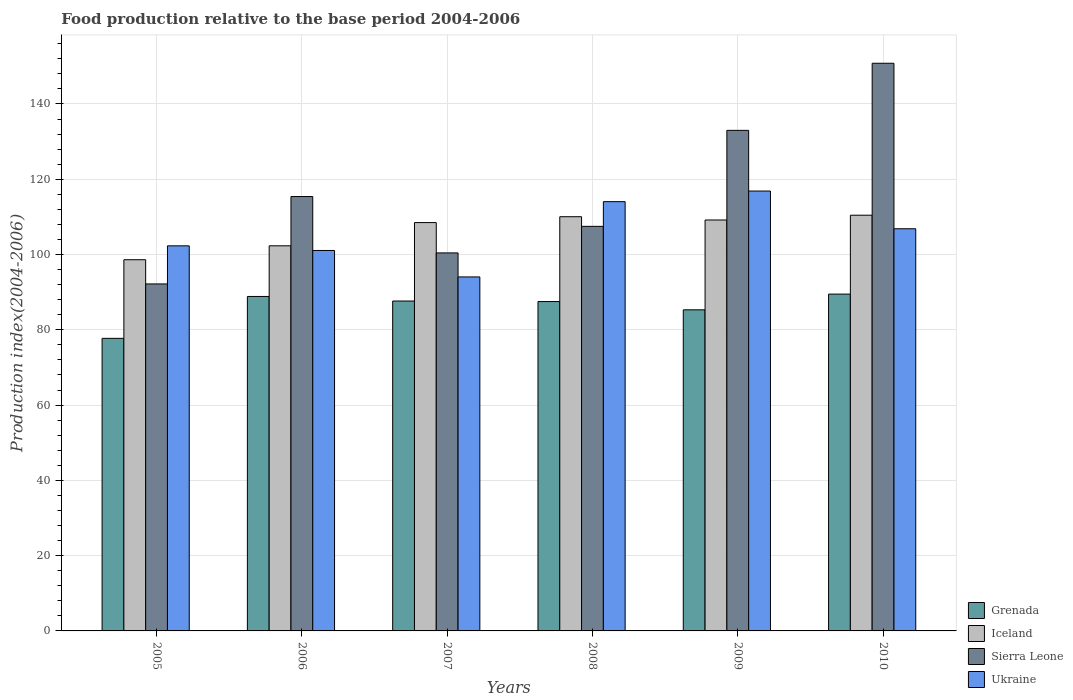How many groups of bars are there?
Keep it short and to the point. 6. Are the number of bars per tick equal to the number of legend labels?
Give a very brief answer. Yes. Are the number of bars on each tick of the X-axis equal?
Provide a short and direct response. Yes. What is the label of the 4th group of bars from the left?
Your answer should be compact. 2008. In how many cases, is the number of bars for a given year not equal to the number of legend labels?
Give a very brief answer. 0. What is the food production index in Grenada in 2010?
Offer a very short reply. 89.49. Across all years, what is the maximum food production index in Iceland?
Offer a terse response. 110.45. Across all years, what is the minimum food production index in Grenada?
Offer a terse response. 77.73. In which year was the food production index in Ukraine maximum?
Offer a very short reply. 2009. What is the total food production index in Ukraine in the graph?
Your response must be concise. 635.21. What is the difference between the food production index in Grenada in 2006 and that in 2010?
Give a very brief answer. -0.63. What is the difference between the food production index in Ukraine in 2005 and the food production index in Grenada in 2009?
Provide a succinct answer. 17. What is the average food production index in Iceland per year?
Offer a terse response. 106.52. In the year 2008, what is the difference between the food production index in Iceland and food production index in Ukraine?
Provide a short and direct response. -4. In how many years, is the food production index in Ukraine greater than 136?
Your response must be concise. 0. What is the ratio of the food production index in Grenada in 2005 to that in 2007?
Give a very brief answer. 0.89. Is the food production index in Iceland in 2006 less than that in 2010?
Offer a very short reply. Yes. Is the difference between the food production index in Iceland in 2009 and 2010 greater than the difference between the food production index in Ukraine in 2009 and 2010?
Ensure brevity in your answer.  No. What is the difference between the highest and the second highest food production index in Iceland?
Provide a short and direct response. 0.4. What is the difference between the highest and the lowest food production index in Iceland?
Provide a short and direct response. 11.83. Is it the case that in every year, the sum of the food production index in Ukraine and food production index in Iceland is greater than the sum of food production index in Sierra Leone and food production index in Grenada?
Provide a short and direct response. No. What does the 1st bar from the left in 2009 represents?
Your answer should be very brief. Grenada. What does the 1st bar from the right in 2008 represents?
Your answer should be very brief. Ukraine. How many bars are there?
Your answer should be compact. 24. Are all the bars in the graph horizontal?
Your response must be concise. No. What is the difference between two consecutive major ticks on the Y-axis?
Your response must be concise. 20. How many legend labels are there?
Offer a very short reply. 4. How are the legend labels stacked?
Provide a short and direct response. Vertical. What is the title of the graph?
Give a very brief answer. Food production relative to the base period 2004-2006. Does "Vanuatu" appear as one of the legend labels in the graph?
Make the answer very short. No. What is the label or title of the Y-axis?
Make the answer very short. Production index(2004-2006). What is the Production index(2004-2006) in Grenada in 2005?
Ensure brevity in your answer.  77.73. What is the Production index(2004-2006) of Iceland in 2005?
Your answer should be compact. 98.62. What is the Production index(2004-2006) in Sierra Leone in 2005?
Your answer should be compact. 92.19. What is the Production index(2004-2006) in Ukraine in 2005?
Your answer should be compact. 102.31. What is the Production index(2004-2006) in Grenada in 2006?
Make the answer very short. 88.86. What is the Production index(2004-2006) in Iceland in 2006?
Your answer should be very brief. 102.32. What is the Production index(2004-2006) of Sierra Leone in 2006?
Ensure brevity in your answer.  115.41. What is the Production index(2004-2006) in Ukraine in 2006?
Make the answer very short. 101.08. What is the Production index(2004-2006) in Grenada in 2007?
Offer a terse response. 87.65. What is the Production index(2004-2006) in Iceland in 2007?
Keep it short and to the point. 108.49. What is the Production index(2004-2006) of Sierra Leone in 2007?
Keep it short and to the point. 100.43. What is the Production index(2004-2006) in Ukraine in 2007?
Your answer should be compact. 94.05. What is the Production index(2004-2006) of Grenada in 2008?
Your response must be concise. 87.51. What is the Production index(2004-2006) of Iceland in 2008?
Provide a succinct answer. 110.05. What is the Production index(2004-2006) in Sierra Leone in 2008?
Offer a very short reply. 107.49. What is the Production index(2004-2006) in Ukraine in 2008?
Provide a succinct answer. 114.05. What is the Production index(2004-2006) of Grenada in 2009?
Give a very brief answer. 85.31. What is the Production index(2004-2006) in Iceland in 2009?
Your response must be concise. 109.18. What is the Production index(2004-2006) in Sierra Leone in 2009?
Your response must be concise. 132.99. What is the Production index(2004-2006) of Ukraine in 2009?
Make the answer very short. 116.87. What is the Production index(2004-2006) of Grenada in 2010?
Provide a succinct answer. 89.49. What is the Production index(2004-2006) of Iceland in 2010?
Offer a terse response. 110.45. What is the Production index(2004-2006) in Sierra Leone in 2010?
Offer a very short reply. 150.82. What is the Production index(2004-2006) in Ukraine in 2010?
Ensure brevity in your answer.  106.85. Across all years, what is the maximum Production index(2004-2006) in Grenada?
Keep it short and to the point. 89.49. Across all years, what is the maximum Production index(2004-2006) of Iceland?
Keep it short and to the point. 110.45. Across all years, what is the maximum Production index(2004-2006) of Sierra Leone?
Give a very brief answer. 150.82. Across all years, what is the maximum Production index(2004-2006) in Ukraine?
Provide a short and direct response. 116.87. Across all years, what is the minimum Production index(2004-2006) in Grenada?
Keep it short and to the point. 77.73. Across all years, what is the minimum Production index(2004-2006) of Iceland?
Your answer should be compact. 98.62. Across all years, what is the minimum Production index(2004-2006) of Sierra Leone?
Provide a succinct answer. 92.19. Across all years, what is the minimum Production index(2004-2006) in Ukraine?
Ensure brevity in your answer.  94.05. What is the total Production index(2004-2006) in Grenada in the graph?
Ensure brevity in your answer.  516.55. What is the total Production index(2004-2006) of Iceland in the graph?
Provide a short and direct response. 639.11. What is the total Production index(2004-2006) of Sierra Leone in the graph?
Give a very brief answer. 699.33. What is the total Production index(2004-2006) in Ukraine in the graph?
Keep it short and to the point. 635.21. What is the difference between the Production index(2004-2006) of Grenada in 2005 and that in 2006?
Offer a very short reply. -11.13. What is the difference between the Production index(2004-2006) in Iceland in 2005 and that in 2006?
Your response must be concise. -3.7. What is the difference between the Production index(2004-2006) of Sierra Leone in 2005 and that in 2006?
Offer a very short reply. -23.22. What is the difference between the Production index(2004-2006) of Ukraine in 2005 and that in 2006?
Your answer should be compact. 1.23. What is the difference between the Production index(2004-2006) of Grenada in 2005 and that in 2007?
Ensure brevity in your answer.  -9.92. What is the difference between the Production index(2004-2006) of Iceland in 2005 and that in 2007?
Your answer should be very brief. -9.87. What is the difference between the Production index(2004-2006) of Sierra Leone in 2005 and that in 2007?
Ensure brevity in your answer.  -8.24. What is the difference between the Production index(2004-2006) in Ukraine in 2005 and that in 2007?
Provide a short and direct response. 8.26. What is the difference between the Production index(2004-2006) of Grenada in 2005 and that in 2008?
Provide a succinct answer. -9.78. What is the difference between the Production index(2004-2006) in Iceland in 2005 and that in 2008?
Give a very brief answer. -11.43. What is the difference between the Production index(2004-2006) of Sierra Leone in 2005 and that in 2008?
Ensure brevity in your answer.  -15.3. What is the difference between the Production index(2004-2006) in Ukraine in 2005 and that in 2008?
Your response must be concise. -11.74. What is the difference between the Production index(2004-2006) in Grenada in 2005 and that in 2009?
Keep it short and to the point. -7.58. What is the difference between the Production index(2004-2006) in Iceland in 2005 and that in 2009?
Give a very brief answer. -10.56. What is the difference between the Production index(2004-2006) in Sierra Leone in 2005 and that in 2009?
Offer a terse response. -40.8. What is the difference between the Production index(2004-2006) of Ukraine in 2005 and that in 2009?
Give a very brief answer. -14.56. What is the difference between the Production index(2004-2006) of Grenada in 2005 and that in 2010?
Make the answer very short. -11.76. What is the difference between the Production index(2004-2006) of Iceland in 2005 and that in 2010?
Keep it short and to the point. -11.83. What is the difference between the Production index(2004-2006) of Sierra Leone in 2005 and that in 2010?
Your answer should be compact. -58.63. What is the difference between the Production index(2004-2006) in Ukraine in 2005 and that in 2010?
Your answer should be very brief. -4.54. What is the difference between the Production index(2004-2006) in Grenada in 2006 and that in 2007?
Keep it short and to the point. 1.21. What is the difference between the Production index(2004-2006) in Iceland in 2006 and that in 2007?
Keep it short and to the point. -6.17. What is the difference between the Production index(2004-2006) in Sierra Leone in 2006 and that in 2007?
Ensure brevity in your answer.  14.98. What is the difference between the Production index(2004-2006) in Ukraine in 2006 and that in 2007?
Your response must be concise. 7.03. What is the difference between the Production index(2004-2006) in Grenada in 2006 and that in 2008?
Your response must be concise. 1.35. What is the difference between the Production index(2004-2006) of Iceland in 2006 and that in 2008?
Provide a succinct answer. -7.73. What is the difference between the Production index(2004-2006) of Sierra Leone in 2006 and that in 2008?
Your response must be concise. 7.92. What is the difference between the Production index(2004-2006) in Ukraine in 2006 and that in 2008?
Give a very brief answer. -12.97. What is the difference between the Production index(2004-2006) of Grenada in 2006 and that in 2009?
Ensure brevity in your answer.  3.55. What is the difference between the Production index(2004-2006) in Iceland in 2006 and that in 2009?
Keep it short and to the point. -6.86. What is the difference between the Production index(2004-2006) of Sierra Leone in 2006 and that in 2009?
Provide a succinct answer. -17.58. What is the difference between the Production index(2004-2006) of Ukraine in 2006 and that in 2009?
Provide a short and direct response. -15.79. What is the difference between the Production index(2004-2006) in Grenada in 2006 and that in 2010?
Offer a very short reply. -0.63. What is the difference between the Production index(2004-2006) of Iceland in 2006 and that in 2010?
Offer a terse response. -8.13. What is the difference between the Production index(2004-2006) of Sierra Leone in 2006 and that in 2010?
Ensure brevity in your answer.  -35.41. What is the difference between the Production index(2004-2006) in Ukraine in 2006 and that in 2010?
Make the answer very short. -5.77. What is the difference between the Production index(2004-2006) in Grenada in 2007 and that in 2008?
Provide a succinct answer. 0.14. What is the difference between the Production index(2004-2006) in Iceland in 2007 and that in 2008?
Ensure brevity in your answer.  -1.56. What is the difference between the Production index(2004-2006) of Sierra Leone in 2007 and that in 2008?
Provide a succinct answer. -7.06. What is the difference between the Production index(2004-2006) of Grenada in 2007 and that in 2009?
Your answer should be compact. 2.34. What is the difference between the Production index(2004-2006) of Iceland in 2007 and that in 2009?
Ensure brevity in your answer.  -0.69. What is the difference between the Production index(2004-2006) in Sierra Leone in 2007 and that in 2009?
Offer a very short reply. -32.56. What is the difference between the Production index(2004-2006) of Ukraine in 2007 and that in 2009?
Provide a succinct answer. -22.82. What is the difference between the Production index(2004-2006) of Grenada in 2007 and that in 2010?
Provide a succinct answer. -1.84. What is the difference between the Production index(2004-2006) of Iceland in 2007 and that in 2010?
Keep it short and to the point. -1.96. What is the difference between the Production index(2004-2006) in Sierra Leone in 2007 and that in 2010?
Give a very brief answer. -50.39. What is the difference between the Production index(2004-2006) of Grenada in 2008 and that in 2009?
Your answer should be compact. 2.2. What is the difference between the Production index(2004-2006) of Iceland in 2008 and that in 2009?
Your response must be concise. 0.87. What is the difference between the Production index(2004-2006) in Sierra Leone in 2008 and that in 2009?
Offer a very short reply. -25.5. What is the difference between the Production index(2004-2006) in Ukraine in 2008 and that in 2009?
Offer a terse response. -2.82. What is the difference between the Production index(2004-2006) of Grenada in 2008 and that in 2010?
Your response must be concise. -1.98. What is the difference between the Production index(2004-2006) in Iceland in 2008 and that in 2010?
Keep it short and to the point. -0.4. What is the difference between the Production index(2004-2006) in Sierra Leone in 2008 and that in 2010?
Ensure brevity in your answer.  -43.33. What is the difference between the Production index(2004-2006) of Ukraine in 2008 and that in 2010?
Make the answer very short. 7.2. What is the difference between the Production index(2004-2006) in Grenada in 2009 and that in 2010?
Your response must be concise. -4.18. What is the difference between the Production index(2004-2006) of Iceland in 2009 and that in 2010?
Offer a very short reply. -1.27. What is the difference between the Production index(2004-2006) in Sierra Leone in 2009 and that in 2010?
Provide a short and direct response. -17.83. What is the difference between the Production index(2004-2006) of Ukraine in 2009 and that in 2010?
Make the answer very short. 10.02. What is the difference between the Production index(2004-2006) of Grenada in 2005 and the Production index(2004-2006) of Iceland in 2006?
Your response must be concise. -24.59. What is the difference between the Production index(2004-2006) of Grenada in 2005 and the Production index(2004-2006) of Sierra Leone in 2006?
Offer a terse response. -37.68. What is the difference between the Production index(2004-2006) in Grenada in 2005 and the Production index(2004-2006) in Ukraine in 2006?
Your answer should be compact. -23.35. What is the difference between the Production index(2004-2006) in Iceland in 2005 and the Production index(2004-2006) in Sierra Leone in 2006?
Ensure brevity in your answer.  -16.79. What is the difference between the Production index(2004-2006) in Iceland in 2005 and the Production index(2004-2006) in Ukraine in 2006?
Your response must be concise. -2.46. What is the difference between the Production index(2004-2006) of Sierra Leone in 2005 and the Production index(2004-2006) of Ukraine in 2006?
Ensure brevity in your answer.  -8.89. What is the difference between the Production index(2004-2006) of Grenada in 2005 and the Production index(2004-2006) of Iceland in 2007?
Offer a very short reply. -30.76. What is the difference between the Production index(2004-2006) of Grenada in 2005 and the Production index(2004-2006) of Sierra Leone in 2007?
Keep it short and to the point. -22.7. What is the difference between the Production index(2004-2006) in Grenada in 2005 and the Production index(2004-2006) in Ukraine in 2007?
Your response must be concise. -16.32. What is the difference between the Production index(2004-2006) in Iceland in 2005 and the Production index(2004-2006) in Sierra Leone in 2007?
Your answer should be compact. -1.81. What is the difference between the Production index(2004-2006) in Iceland in 2005 and the Production index(2004-2006) in Ukraine in 2007?
Offer a very short reply. 4.57. What is the difference between the Production index(2004-2006) of Sierra Leone in 2005 and the Production index(2004-2006) of Ukraine in 2007?
Offer a very short reply. -1.86. What is the difference between the Production index(2004-2006) in Grenada in 2005 and the Production index(2004-2006) in Iceland in 2008?
Your answer should be very brief. -32.32. What is the difference between the Production index(2004-2006) of Grenada in 2005 and the Production index(2004-2006) of Sierra Leone in 2008?
Ensure brevity in your answer.  -29.76. What is the difference between the Production index(2004-2006) in Grenada in 2005 and the Production index(2004-2006) in Ukraine in 2008?
Give a very brief answer. -36.32. What is the difference between the Production index(2004-2006) of Iceland in 2005 and the Production index(2004-2006) of Sierra Leone in 2008?
Ensure brevity in your answer.  -8.87. What is the difference between the Production index(2004-2006) of Iceland in 2005 and the Production index(2004-2006) of Ukraine in 2008?
Your answer should be very brief. -15.43. What is the difference between the Production index(2004-2006) of Sierra Leone in 2005 and the Production index(2004-2006) of Ukraine in 2008?
Your response must be concise. -21.86. What is the difference between the Production index(2004-2006) in Grenada in 2005 and the Production index(2004-2006) in Iceland in 2009?
Offer a terse response. -31.45. What is the difference between the Production index(2004-2006) of Grenada in 2005 and the Production index(2004-2006) of Sierra Leone in 2009?
Make the answer very short. -55.26. What is the difference between the Production index(2004-2006) of Grenada in 2005 and the Production index(2004-2006) of Ukraine in 2009?
Keep it short and to the point. -39.14. What is the difference between the Production index(2004-2006) of Iceland in 2005 and the Production index(2004-2006) of Sierra Leone in 2009?
Your answer should be very brief. -34.37. What is the difference between the Production index(2004-2006) of Iceland in 2005 and the Production index(2004-2006) of Ukraine in 2009?
Your answer should be very brief. -18.25. What is the difference between the Production index(2004-2006) of Sierra Leone in 2005 and the Production index(2004-2006) of Ukraine in 2009?
Ensure brevity in your answer.  -24.68. What is the difference between the Production index(2004-2006) in Grenada in 2005 and the Production index(2004-2006) in Iceland in 2010?
Keep it short and to the point. -32.72. What is the difference between the Production index(2004-2006) of Grenada in 2005 and the Production index(2004-2006) of Sierra Leone in 2010?
Your answer should be compact. -73.09. What is the difference between the Production index(2004-2006) of Grenada in 2005 and the Production index(2004-2006) of Ukraine in 2010?
Give a very brief answer. -29.12. What is the difference between the Production index(2004-2006) in Iceland in 2005 and the Production index(2004-2006) in Sierra Leone in 2010?
Your answer should be compact. -52.2. What is the difference between the Production index(2004-2006) in Iceland in 2005 and the Production index(2004-2006) in Ukraine in 2010?
Ensure brevity in your answer.  -8.23. What is the difference between the Production index(2004-2006) in Sierra Leone in 2005 and the Production index(2004-2006) in Ukraine in 2010?
Keep it short and to the point. -14.66. What is the difference between the Production index(2004-2006) of Grenada in 2006 and the Production index(2004-2006) of Iceland in 2007?
Provide a succinct answer. -19.63. What is the difference between the Production index(2004-2006) of Grenada in 2006 and the Production index(2004-2006) of Sierra Leone in 2007?
Provide a short and direct response. -11.57. What is the difference between the Production index(2004-2006) in Grenada in 2006 and the Production index(2004-2006) in Ukraine in 2007?
Make the answer very short. -5.19. What is the difference between the Production index(2004-2006) in Iceland in 2006 and the Production index(2004-2006) in Sierra Leone in 2007?
Provide a short and direct response. 1.89. What is the difference between the Production index(2004-2006) in Iceland in 2006 and the Production index(2004-2006) in Ukraine in 2007?
Give a very brief answer. 8.27. What is the difference between the Production index(2004-2006) of Sierra Leone in 2006 and the Production index(2004-2006) of Ukraine in 2007?
Your answer should be compact. 21.36. What is the difference between the Production index(2004-2006) in Grenada in 2006 and the Production index(2004-2006) in Iceland in 2008?
Ensure brevity in your answer.  -21.19. What is the difference between the Production index(2004-2006) of Grenada in 2006 and the Production index(2004-2006) of Sierra Leone in 2008?
Your response must be concise. -18.63. What is the difference between the Production index(2004-2006) of Grenada in 2006 and the Production index(2004-2006) of Ukraine in 2008?
Keep it short and to the point. -25.19. What is the difference between the Production index(2004-2006) of Iceland in 2006 and the Production index(2004-2006) of Sierra Leone in 2008?
Ensure brevity in your answer.  -5.17. What is the difference between the Production index(2004-2006) of Iceland in 2006 and the Production index(2004-2006) of Ukraine in 2008?
Your response must be concise. -11.73. What is the difference between the Production index(2004-2006) in Sierra Leone in 2006 and the Production index(2004-2006) in Ukraine in 2008?
Ensure brevity in your answer.  1.36. What is the difference between the Production index(2004-2006) of Grenada in 2006 and the Production index(2004-2006) of Iceland in 2009?
Offer a very short reply. -20.32. What is the difference between the Production index(2004-2006) of Grenada in 2006 and the Production index(2004-2006) of Sierra Leone in 2009?
Your answer should be very brief. -44.13. What is the difference between the Production index(2004-2006) in Grenada in 2006 and the Production index(2004-2006) in Ukraine in 2009?
Keep it short and to the point. -28.01. What is the difference between the Production index(2004-2006) of Iceland in 2006 and the Production index(2004-2006) of Sierra Leone in 2009?
Your answer should be compact. -30.67. What is the difference between the Production index(2004-2006) of Iceland in 2006 and the Production index(2004-2006) of Ukraine in 2009?
Provide a succinct answer. -14.55. What is the difference between the Production index(2004-2006) in Sierra Leone in 2006 and the Production index(2004-2006) in Ukraine in 2009?
Offer a very short reply. -1.46. What is the difference between the Production index(2004-2006) in Grenada in 2006 and the Production index(2004-2006) in Iceland in 2010?
Ensure brevity in your answer.  -21.59. What is the difference between the Production index(2004-2006) in Grenada in 2006 and the Production index(2004-2006) in Sierra Leone in 2010?
Offer a very short reply. -61.96. What is the difference between the Production index(2004-2006) of Grenada in 2006 and the Production index(2004-2006) of Ukraine in 2010?
Your answer should be very brief. -17.99. What is the difference between the Production index(2004-2006) of Iceland in 2006 and the Production index(2004-2006) of Sierra Leone in 2010?
Give a very brief answer. -48.5. What is the difference between the Production index(2004-2006) of Iceland in 2006 and the Production index(2004-2006) of Ukraine in 2010?
Provide a succinct answer. -4.53. What is the difference between the Production index(2004-2006) of Sierra Leone in 2006 and the Production index(2004-2006) of Ukraine in 2010?
Offer a very short reply. 8.56. What is the difference between the Production index(2004-2006) in Grenada in 2007 and the Production index(2004-2006) in Iceland in 2008?
Your answer should be compact. -22.4. What is the difference between the Production index(2004-2006) of Grenada in 2007 and the Production index(2004-2006) of Sierra Leone in 2008?
Offer a terse response. -19.84. What is the difference between the Production index(2004-2006) in Grenada in 2007 and the Production index(2004-2006) in Ukraine in 2008?
Your response must be concise. -26.4. What is the difference between the Production index(2004-2006) in Iceland in 2007 and the Production index(2004-2006) in Sierra Leone in 2008?
Offer a terse response. 1. What is the difference between the Production index(2004-2006) in Iceland in 2007 and the Production index(2004-2006) in Ukraine in 2008?
Provide a short and direct response. -5.56. What is the difference between the Production index(2004-2006) of Sierra Leone in 2007 and the Production index(2004-2006) of Ukraine in 2008?
Your response must be concise. -13.62. What is the difference between the Production index(2004-2006) in Grenada in 2007 and the Production index(2004-2006) in Iceland in 2009?
Provide a short and direct response. -21.53. What is the difference between the Production index(2004-2006) in Grenada in 2007 and the Production index(2004-2006) in Sierra Leone in 2009?
Provide a succinct answer. -45.34. What is the difference between the Production index(2004-2006) of Grenada in 2007 and the Production index(2004-2006) of Ukraine in 2009?
Provide a short and direct response. -29.22. What is the difference between the Production index(2004-2006) of Iceland in 2007 and the Production index(2004-2006) of Sierra Leone in 2009?
Ensure brevity in your answer.  -24.5. What is the difference between the Production index(2004-2006) in Iceland in 2007 and the Production index(2004-2006) in Ukraine in 2009?
Your answer should be compact. -8.38. What is the difference between the Production index(2004-2006) of Sierra Leone in 2007 and the Production index(2004-2006) of Ukraine in 2009?
Keep it short and to the point. -16.44. What is the difference between the Production index(2004-2006) in Grenada in 2007 and the Production index(2004-2006) in Iceland in 2010?
Provide a short and direct response. -22.8. What is the difference between the Production index(2004-2006) in Grenada in 2007 and the Production index(2004-2006) in Sierra Leone in 2010?
Your answer should be compact. -63.17. What is the difference between the Production index(2004-2006) of Grenada in 2007 and the Production index(2004-2006) of Ukraine in 2010?
Your answer should be very brief. -19.2. What is the difference between the Production index(2004-2006) in Iceland in 2007 and the Production index(2004-2006) in Sierra Leone in 2010?
Keep it short and to the point. -42.33. What is the difference between the Production index(2004-2006) in Iceland in 2007 and the Production index(2004-2006) in Ukraine in 2010?
Your response must be concise. 1.64. What is the difference between the Production index(2004-2006) in Sierra Leone in 2007 and the Production index(2004-2006) in Ukraine in 2010?
Provide a short and direct response. -6.42. What is the difference between the Production index(2004-2006) of Grenada in 2008 and the Production index(2004-2006) of Iceland in 2009?
Ensure brevity in your answer.  -21.67. What is the difference between the Production index(2004-2006) of Grenada in 2008 and the Production index(2004-2006) of Sierra Leone in 2009?
Make the answer very short. -45.48. What is the difference between the Production index(2004-2006) in Grenada in 2008 and the Production index(2004-2006) in Ukraine in 2009?
Your answer should be very brief. -29.36. What is the difference between the Production index(2004-2006) in Iceland in 2008 and the Production index(2004-2006) in Sierra Leone in 2009?
Your answer should be compact. -22.94. What is the difference between the Production index(2004-2006) of Iceland in 2008 and the Production index(2004-2006) of Ukraine in 2009?
Provide a succinct answer. -6.82. What is the difference between the Production index(2004-2006) in Sierra Leone in 2008 and the Production index(2004-2006) in Ukraine in 2009?
Make the answer very short. -9.38. What is the difference between the Production index(2004-2006) of Grenada in 2008 and the Production index(2004-2006) of Iceland in 2010?
Ensure brevity in your answer.  -22.94. What is the difference between the Production index(2004-2006) of Grenada in 2008 and the Production index(2004-2006) of Sierra Leone in 2010?
Keep it short and to the point. -63.31. What is the difference between the Production index(2004-2006) in Grenada in 2008 and the Production index(2004-2006) in Ukraine in 2010?
Offer a terse response. -19.34. What is the difference between the Production index(2004-2006) of Iceland in 2008 and the Production index(2004-2006) of Sierra Leone in 2010?
Your response must be concise. -40.77. What is the difference between the Production index(2004-2006) of Iceland in 2008 and the Production index(2004-2006) of Ukraine in 2010?
Make the answer very short. 3.2. What is the difference between the Production index(2004-2006) of Sierra Leone in 2008 and the Production index(2004-2006) of Ukraine in 2010?
Your answer should be compact. 0.64. What is the difference between the Production index(2004-2006) of Grenada in 2009 and the Production index(2004-2006) of Iceland in 2010?
Offer a very short reply. -25.14. What is the difference between the Production index(2004-2006) in Grenada in 2009 and the Production index(2004-2006) in Sierra Leone in 2010?
Keep it short and to the point. -65.51. What is the difference between the Production index(2004-2006) of Grenada in 2009 and the Production index(2004-2006) of Ukraine in 2010?
Provide a succinct answer. -21.54. What is the difference between the Production index(2004-2006) of Iceland in 2009 and the Production index(2004-2006) of Sierra Leone in 2010?
Your answer should be very brief. -41.64. What is the difference between the Production index(2004-2006) in Iceland in 2009 and the Production index(2004-2006) in Ukraine in 2010?
Offer a very short reply. 2.33. What is the difference between the Production index(2004-2006) of Sierra Leone in 2009 and the Production index(2004-2006) of Ukraine in 2010?
Your answer should be compact. 26.14. What is the average Production index(2004-2006) in Grenada per year?
Offer a terse response. 86.09. What is the average Production index(2004-2006) of Iceland per year?
Provide a succinct answer. 106.52. What is the average Production index(2004-2006) in Sierra Leone per year?
Offer a very short reply. 116.56. What is the average Production index(2004-2006) in Ukraine per year?
Your answer should be compact. 105.87. In the year 2005, what is the difference between the Production index(2004-2006) of Grenada and Production index(2004-2006) of Iceland?
Give a very brief answer. -20.89. In the year 2005, what is the difference between the Production index(2004-2006) in Grenada and Production index(2004-2006) in Sierra Leone?
Provide a short and direct response. -14.46. In the year 2005, what is the difference between the Production index(2004-2006) of Grenada and Production index(2004-2006) of Ukraine?
Keep it short and to the point. -24.58. In the year 2005, what is the difference between the Production index(2004-2006) of Iceland and Production index(2004-2006) of Sierra Leone?
Your response must be concise. 6.43. In the year 2005, what is the difference between the Production index(2004-2006) in Iceland and Production index(2004-2006) in Ukraine?
Offer a very short reply. -3.69. In the year 2005, what is the difference between the Production index(2004-2006) in Sierra Leone and Production index(2004-2006) in Ukraine?
Ensure brevity in your answer.  -10.12. In the year 2006, what is the difference between the Production index(2004-2006) in Grenada and Production index(2004-2006) in Iceland?
Keep it short and to the point. -13.46. In the year 2006, what is the difference between the Production index(2004-2006) of Grenada and Production index(2004-2006) of Sierra Leone?
Offer a very short reply. -26.55. In the year 2006, what is the difference between the Production index(2004-2006) in Grenada and Production index(2004-2006) in Ukraine?
Offer a terse response. -12.22. In the year 2006, what is the difference between the Production index(2004-2006) in Iceland and Production index(2004-2006) in Sierra Leone?
Your answer should be very brief. -13.09. In the year 2006, what is the difference between the Production index(2004-2006) in Iceland and Production index(2004-2006) in Ukraine?
Provide a short and direct response. 1.24. In the year 2006, what is the difference between the Production index(2004-2006) of Sierra Leone and Production index(2004-2006) of Ukraine?
Your response must be concise. 14.33. In the year 2007, what is the difference between the Production index(2004-2006) of Grenada and Production index(2004-2006) of Iceland?
Offer a very short reply. -20.84. In the year 2007, what is the difference between the Production index(2004-2006) in Grenada and Production index(2004-2006) in Sierra Leone?
Your response must be concise. -12.78. In the year 2007, what is the difference between the Production index(2004-2006) in Iceland and Production index(2004-2006) in Sierra Leone?
Your answer should be compact. 8.06. In the year 2007, what is the difference between the Production index(2004-2006) in Iceland and Production index(2004-2006) in Ukraine?
Offer a terse response. 14.44. In the year 2007, what is the difference between the Production index(2004-2006) of Sierra Leone and Production index(2004-2006) of Ukraine?
Your answer should be compact. 6.38. In the year 2008, what is the difference between the Production index(2004-2006) of Grenada and Production index(2004-2006) of Iceland?
Keep it short and to the point. -22.54. In the year 2008, what is the difference between the Production index(2004-2006) of Grenada and Production index(2004-2006) of Sierra Leone?
Your response must be concise. -19.98. In the year 2008, what is the difference between the Production index(2004-2006) in Grenada and Production index(2004-2006) in Ukraine?
Give a very brief answer. -26.54. In the year 2008, what is the difference between the Production index(2004-2006) in Iceland and Production index(2004-2006) in Sierra Leone?
Make the answer very short. 2.56. In the year 2008, what is the difference between the Production index(2004-2006) in Iceland and Production index(2004-2006) in Ukraine?
Your answer should be very brief. -4. In the year 2008, what is the difference between the Production index(2004-2006) in Sierra Leone and Production index(2004-2006) in Ukraine?
Provide a succinct answer. -6.56. In the year 2009, what is the difference between the Production index(2004-2006) in Grenada and Production index(2004-2006) in Iceland?
Provide a short and direct response. -23.87. In the year 2009, what is the difference between the Production index(2004-2006) in Grenada and Production index(2004-2006) in Sierra Leone?
Your answer should be compact. -47.68. In the year 2009, what is the difference between the Production index(2004-2006) of Grenada and Production index(2004-2006) of Ukraine?
Provide a short and direct response. -31.56. In the year 2009, what is the difference between the Production index(2004-2006) of Iceland and Production index(2004-2006) of Sierra Leone?
Your answer should be very brief. -23.81. In the year 2009, what is the difference between the Production index(2004-2006) in Iceland and Production index(2004-2006) in Ukraine?
Provide a short and direct response. -7.69. In the year 2009, what is the difference between the Production index(2004-2006) of Sierra Leone and Production index(2004-2006) of Ukraine?
Ensure brevity in your answer.  16.12. In the year 2010, what is the difference between the Production index(2004-2006) of Grenada and Production index(2004-2006) of Iceland?
Your response must be concise. -20.96. In the year 2010, what is the difference between the Production index(2004-2006) in Grenada and Production index(2004-2006) in Sierra Leone?
Provide a succinct answer. -61.33. In the year 2010, what is the difference between the Production index(2004-2006) of Grenada and Production index(2004-2006) of Ukraine?
Your answer should be very brief. -17.36. In the year 2010, what is the difference between the Production index(2004-2006) of Iceland and Production index(2004-2006) of Sierra Leone?
Keep it short and to the point. -40.37. In the year 2010, what is the difference between the Production index(2004-2006) in Sierra Leone and Production index(2004-2006) in Ukraine?
Ensure brevity in your answer.  43.97. What is the ratio of the Production index(2004-2006) of Grenada in 2005 to that in 2006?
Offer a terse response. 0.87. What is the ratio of the Production index(2004-2006) of Iceland in 2005 to that in 2006?
Your answer should be very brief. 0.96. What is the ratio of the Production index(2004-2006) in Sierra Leone in 2005 to that in 2006?
Offer a very short reply. 0.8. What is the ratio of the Production index(2004-2006) in Ukraine in 2005 to that in 2006?
Offer a terse response. 1.01. What is the ratio of the Production index(2004-2006) of Grenada in 2005 to that in 2007?
Make the answer very short. 0.89. What is the ratio of the Production index(2004-2006) of Iceland in 2005 to that in 2007?
Ensure brevity in your answer.  0.91. What is the ratio of the Production index(2004-2006) of Sierra Leone in 2005 to that in 2007?
Make the answer very short. 0.92. What is the ratio of the Production index(2004-2006) of Ukraine in 2005 to that in 2007?
Provide a succinct answer. 1.09. What is the ratio of the Production index(2004-2006) in Grenada in 2005 to that in 2008?
Your answer should be compact. 0.89. What is the ratio of the Production index(2004-2006) in Iceland in 2005 to that in 2008?
Make the answer very short. 0.9. What is the ratio of the Production index(2004-2006) of Sierra Leone in 2005 to that in 2008?
Keep it short and to the point. 0.86. What is the ratio of the Production index(2004-2006) in Ukraine in 2005 to that in 2008?
Provide a short and direct response. 0.9. What is the ratio of the Production index(2004-2006) in Grenada in 2005 to that in 2009?
Give a very brief answer. 0.91. What is the ratio of the Production index(2004-2006) of Iceland in 2005 to that in 2009?
Provide a short and direct response. 0.9. What is the ratio of the Production index(2004-2006) of Sierra Leone in 2005 to that in 2009?
Keep it short and to the point. 0.69. What is the ratio of the Production index(2004-2006) in Ukraine in 2005 to that in 2009?
Offer a very short reply. 0.88. What is the ratio of the Production index(2004-2006) in Grenada in 2005 to that in 2010?
Provide a short and direct response. 0.87. What is the ratio of the Production index(2004-2006) of Iceland in 2005 to that in 2010?
Provide a short and direct response. 0.89. What is the ratio of the Production index(2004-2006) in Sierra Leone in 2005 to that in 2010?
Give a very brief answer. 0.61. What is the ratio of the Production index(2004-2006) in Ukraine in 2005 to that in 2010?
Your response must be concise. 0.96. What is the ratio of the Production index(2004-2006) in Grenada in 2006 to that in 2007?
Your response must be concise. 1.01. What is the ratio of the Production index(2004-2006) of Iceland in 2006 to that in 2007?
Your answer should be very brief. 0.94. What is the ratio of the Production index(2004-2006) in Sierra Leone in 2006 to that in 2007?
Offer a very short reply. 1.15. What is the ratio of the Production index(2004-2006) of Ukraine in 2006 to that in 2007?
Provide a succinct answer. 1.07. What is the ratio of the Production index(2004-2006) in Grenada in 2006 to that in 2008?
Your answer should be very brief. 1.02. What is the ratio of the Production index(2004-2006) of Iceland in 2006 to that in 2008?
Keep it short and to the point. 0.93. What is the ratio of the Production index(2004-2006) of Sierra Leone in 2006 to that in 2008?
Provide a short and direct response. 1.07. What is the ratio of the Production index(2004-2006) of Ukraine in 2006 to that in 2008?
Offer a very short reply. 0.89. What is the ratio of the Production index(2004-2006) in Grenada in 2006 to that in 2009?
Offer a very short reply. 1.04. What is the ratio of the Production index(2004-2006) in Iceland in 2006 to that in 2009?
Ensure brevity in your answer.  0.94. What is the ratio of the Production index(2004-2006) in Sierra Leone in 2006 to that in 2009?
Your response must be concise. 0.87. What is the ratio of the Production index(2004-2006) in Ukraine in 2006 to that in 2009?
Make the answer very short. 0.86. What is the ratio of the Production index(2004-2006) of Iceland in 2006 to that in 2010?
Provide a succinct answer. 0.93. What is the ratio of the Production index(2004-2006) of Sierra Leone in 2006 to that in 2010?
Provide a succinct answer. 0.77. What is the ratio of the Production index(2004-2006) of Ukraine in 2006 to that in 2010?
Ensure brevity in your answer.  0.95. What is the ratio of the Production index(2004-2006) of Grenada in 2007 to that in 2008?
Keep it short and to the point. 1. What is the ratio of the Production index(2004-2006) of Iceland in 2007 to that in 2008?
Your answer should be compact. 0.99. What is the ratio of the Production index(2004-2006) of Sierra Leone in 2007 to that in 2008?
Provide a succinct answer. 0.93. What is the ratio of the Production index(2004-2006) in Ukraine in 2007 to that in 2008?
Give a very brief answer. 0.82. What is the ratio of the Production index(2004-2006) in Grenada in 2007 to that in 2009?
Offer a terse response. 1.03. What is the ratio of the Production index(2004-2006) in Sierra Leone in 2007 to that in 2009?
Your answer should be very brief. 0.76. What is the ratio of the Production index(2004-2006) in Ukraine in 2007 to that in 2009?
Provide a succinct answer. 0.8. What is the ratio of the Production index(2004-2006) of Grenada in 2007 to that in 2010?
Your response must be concise. 0.98. What is the ratio of the Production index(2004-2006) of Iceland in 2007 to that in 2010?
Your answer should be compact. 0.98. What is the ratio of the Production index(2004-2006) of Sierra Leone in 2007 to that in 2010?
Give a very brief answer. 0.67. What is the ratio of the Production index(2004-2006) in Ukraine in 2007 to that in 2010?
Your answer should be compact. 0.88. What is the ratio of the Production index(2004-2006) of Grenada in 2008 to that in 2009?
Offer a very short reply. 1.03. What is the ratio of the Production index(2004-2006) in Iceland in 2008 to that in 2009?
Keep it short and to the point. 1.01. What is the ratio of the Production index(2004-2006) in Sierra Leone in 2008 to that in 2009?
Offer a terse response. 0.81. What is the ratio of the Production index(2004-2006) in Ukraine in 2008 to that in 2009?
Provide a succinct answer. 0.98. What is the ratio of the Production index(2004-2006) in Grenada in 2008 to that in 2010?
Your answer should be very brief. 0.98. What is the ratio of the Production index(2004-2006) in Sierra Leone in 2008 to that in 2010?
Your answer should be very brief. 0.71. What is the ratio of the Production index(2004-2006) of Ukraine in 2008 to that in 2010?
Ensure brevity in your answer.  1.07. What is the ratio of the Production index(2004-2006) in Grenada in 2009 to that in 2010?
Your answer should be very brief. 0.95. What is the ratio of the Production index(2004-2006) in Iceland in 2009 to that in 2010?
Keep it short and to the point. 0.99. What is the ratio of the Production index(2004-2006) in Sierra Leone in 2009 to that in 2010?
Your response must be concise. 0.88. What is the ratio of the Production index(2004-2006) in Ukraine in 2009 to that in 2010?
Provide a short and direct response. 1.09. What is the difference between the highest and the second highest Production index(2004-2006) in Grenada?
Offer a terse response. 0.63. What is the difference between the highest and the second highest Production index(2004-2006) of Iceland?
Your response must be concise. 0.4. What is the difference between the highest and the second highest Production index(2004-2006) of Sierra Leone?
Keep it short and to the point. 17.83. What is the difference between the highest and the second highest Production index(2004-2006) in Ukraine?
Ensure brevity in your answer.  2.82. What is the difference between the highest and the lowest Production index(2004-2006) in Grenada?
Your answer should be very brief. 11.76. What is the difference between the highest and the lowest Production index(2004-2006) of Iceland?
Your response must be concise. 11.83. What is the difference between the highest and the lowest Production index(2004-2006) in Sierra Leone?
Provide a short and direct response. 58.63. What is the difference between the highest and the lowest Production index(2004-2006) of Ukraine?
Ensure brevity in your answer.  22.82. 